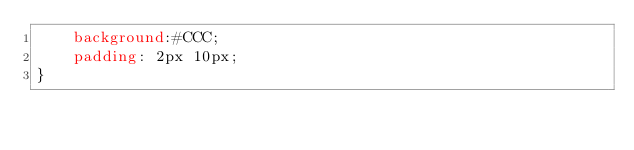<code> <loc_0><loc_0><loc_500><loc_500><_CSS_>    background:#CCC;
    padding: 2px 10px;
}</code> 